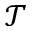Convert formula to latex. <formula><loc_0><loc_0><loc_500><loc_500>\mathcal { T }</formula> 